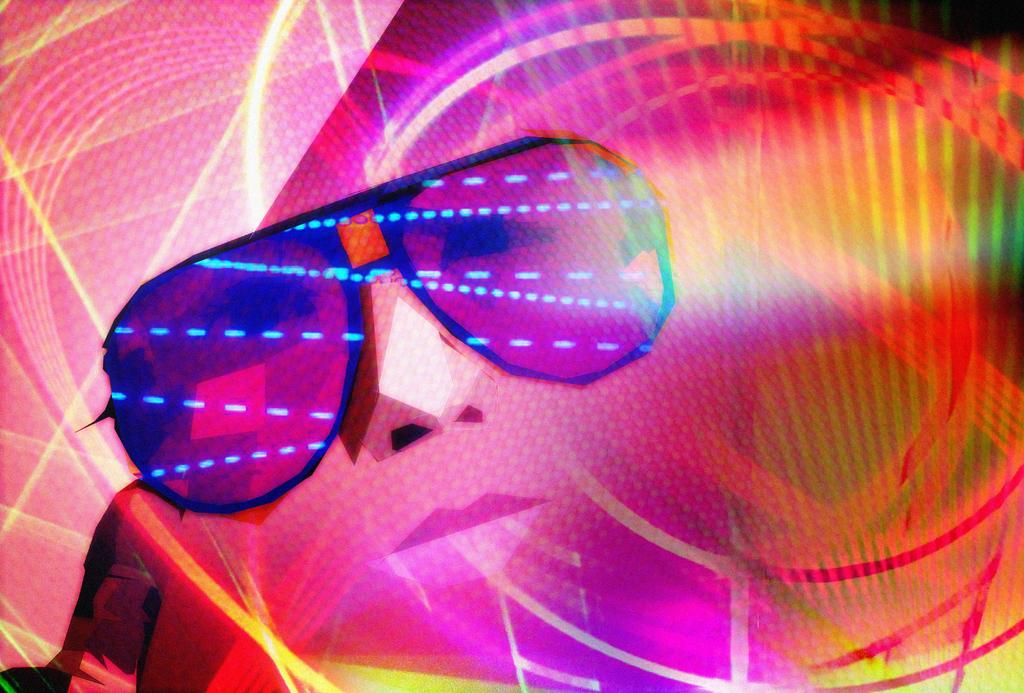What can be observed about the image's appearance? The image is edited. What is the main subject of the image? There is a person's face in the image. What is the person wearing in the image? The person is wearing goggles in the image. Can you tell me which actor is performing in the image? There is no actor performing in the image, as it features a person's face wearing goggles. Is there any smoke visible in the image? There is no smoke present in the image. 